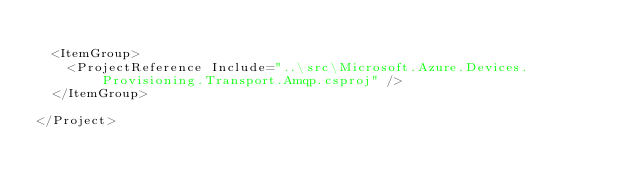<code> <loc_0><loc_0><loc_500><loc_500><_XML_>
  <ItemGroup>
    <ProjectReference Include="..\src\Microsoft.Azure.Devices.Provisioning.Transport.Amqp.csproj" />
  </ItemGroup>

</Project>
</code> 